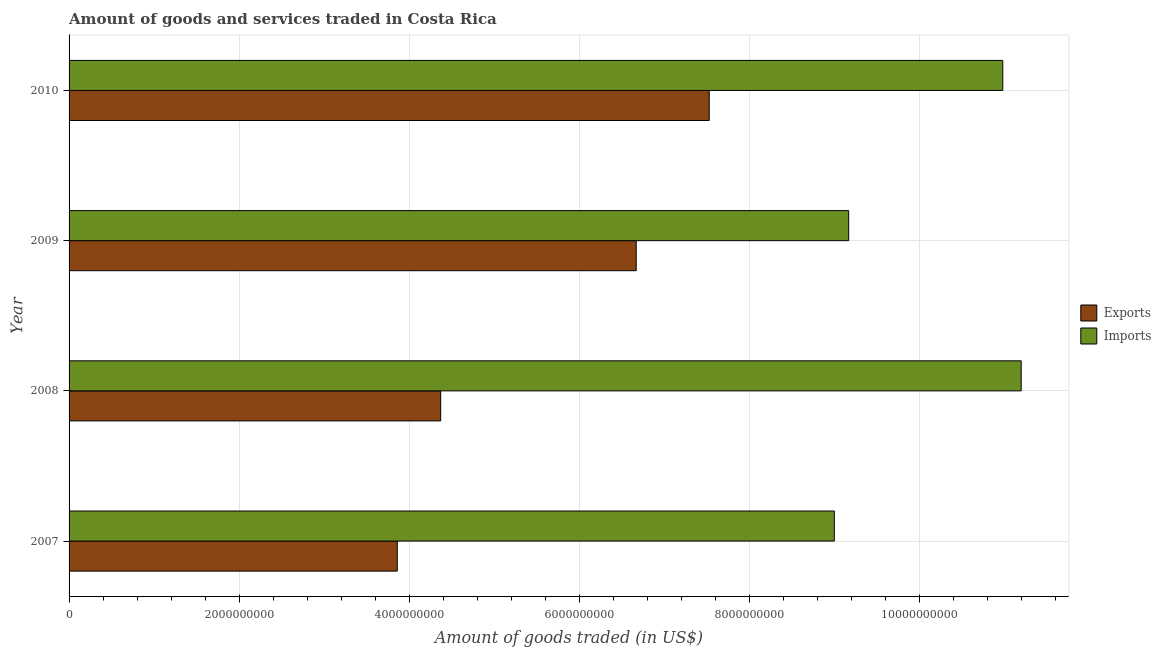Are the number of bars per tick equal to the number of legend labels?
Offer a very short reply. Yes. How many bars are there on the 4th tick from the top?
Your answer should be very brief. 2. How many bars are there on the 2nd tick from the bottom?
Keep it short and to the point. 2. In how many cases, is the number of bars for a given year not equal to the number of legend labels?
Give a very brief answer. 0. What is the amount of goods exported in 2010?
Your response must be concise. 7.53e+09. Across all years, what is the maximum amount of goods exported?
Your response must be concise. 7.53e+09. Across all years, what is the minimum amount of goods imported?
Provide a succinct answer. 9.00e+09. What is the total amount of goods exported in the graph?
Ensure brevity in your answer.  2.24e+1. What is the difference between the amount of goods exported in 2008 and that in 2010?
Offer a terse response. -3.16e+09. What is the difference between the amount of goods imported in 2008 and the amount of goods exported in 2010?
Keep it short and to the point. 3.67e+09. What is the average amount of goods exported per year?
Your response must be concise. 5.61e+09. In the year 2010, what is the difference between the amount of goods exported and amount of goods imported?
Keep it short and to the point. -3.45e+09. In how many years, is the amount of goods exported greater than 6800000000 US$?
Keep it short and to the point. 1. What is the ratio of the amount of goods exported in 2008 to that in 2009?
Your answer should be compact. 0.66. What is the difference between the highest and the second highest amount of goods imported?
Keep it short and to the point. 2.17e+08. What is the difference between the highest and the lowest amount of goods imported?
Your response must be concise. 2.20e+09. What does the 1st bar from the top in 2008 represents?
Offer a terse response. Imports. What does the 2nd bar from the bottom in 2009 represents?
Your answer should be very brief. Imports. Are all the bars in the graph horizontal?
Offer a very short reply. Yes. How many years are there in the graph?
Give a very brief answer. 4. How many legend labels are there?
Your answer should be very brief. 2. What is the title of the graph?
Your answer should be very brief. Amount of goods and services traded in Costa Rica. What is the label or title of the X-axis?
Provide a short and direct response. Amount of goods traded (in US$). What is the Amount of goods traded (in US$) in Exports in 2007?
Offer a terse response. 3.86e+09. What is the Amount of goods traded (in US$) in Imports in 2007?
Your response must be concise. 9.00e+09. What is the Amount of goods traded (in US$) in Exports in 2008?
Ensure brevity in your answer.  4.37e+09. What is the Amount of goods traded (in US$) in Imports in 2008?
Your response must be concise. 1.12e+1. What is the Amount of goods traded (in US$) in Exports in 2009?
Make the answer very short. 6.67e+09. What is the Amount of goods traded (in US$) of Imports in 2009?
Provide a succinct answer. 9.17e+09. What is the Amount of goods traded (in US$) in Exports in 2010?
Make the answer very short. 7.53e+09. What is the Amount of goods traded (in US$) of Imports in 2010?
Give a very brief answer. 1.10e+1. Across all years, what is the maximum Amount of goods traded (in US$) in Exports?
Offer a very short reply. 7.53e+09. Across all years, what is the maximum Amount of goods traded (in US$) in Imports?
Provide a succinct answer. 1.12e+1. Across all years, what is the minimum Amount of goods traded (in US$) in Exports?
Ensure brevity in your answer.  3.86e+09. Across all years, what is the minimum Amount of goods traded (in US$) in Imports?
Offer a very short reply. 9.00e+09. What is the total Amount of goods traded (in US$) of Exports in the graph?
Provide a succinct answer. 2.24e+1. What is the total Amount of goods traded (in US$) in Imports in the graph?
Offer a terse response. 4.04e+1. What is the difference between the Amount of goods traded (in US$) in Exports in 2007 and that in 2008?
Make the answer very short. -5.10e+08. What is the difference between the Amount of goods traded (in US$) in Imports in 2007 and that in 2008?
Make the answer very short. -2.20e+09. What is the difference between the Amount of goods traded (in US$) in Exports in 2007 and that in 2009?
Give a very brief answer. -2.81e+09. What is the difference between the Amount of goods traded (in US$) of Imports in 2007 and that in 2009?
Keep it short and to the point. -1.69e+08. What is the difference between the Amount of goods traded (in US$) of Exports in 2007 and that in 2010?
Your answer should be compact. -3.67e+09. What is the difference between the Amount of goods traded (in US$) in Imports in 2007 and that in 2010?
Keep it short and to the point. -1.98e+09. What is the difference between the Amount of goods traded (in US$) in Exports in 2008 and that in 2009?
Offer a terse response. -2.30e+09. What is the difference between the Amount of goods traded (in US$) of Imports in 2008 and that in 2009?
Make the answer very short. 2.03e+09. What is the difference between the Amount of goods traded (in US$) of Exports in 2008 and that in 2010?
Ensure brevity in your answer.  -3.16e+09. What is the difference between the Amount of goods traded (in US$) in Imports in 2008 and that in 2010?
Your answer should be compact. 2.17e+08. What is the difference between the Amount of goods traded (in US$) of Exports in 2009 and that in 2010?
Give a very brief answer. -8.59e+08. What is the difference between the Amount of goods traded (in US$) of Imports in 2009 and that in 2010?
Your response must be concise. -1.81e+09. What is the difference between the Amount of goods traded (in US$) in Exports in 2007 and the Amount of goods traded (in US$) in Imports in 2008?
Your answer should be very brief. -7.34e+09. What is the difference between the Amount of goods traded (in US$) in Exports in 2007 and the Amount of goods traded (in US$) in Imports in 2009?
Offer a terse response. -5.31e+09. What is the difference between the Amount of goods traded (in US$) of Exports in 2007 and the Amount of goods traded (in US$) of Imports in 2010?
Your answer should be compact. -7.12e+09. What is the difference between the Amount of goods traded (in US$) in Exports in 2008 and the Amount of goods traded (in US$) in Imports in 2009?
Keep it short and to the point. -4.80e+09. What is the difference between the Amount of goods traded (in US$) in Exports in 2008 and the Amount of goods traded (in US$) in Imports in 2010?
Keep it short and to the point. -6.61e+09. What is the difference between the Amount of goods traded (in US$) of Exports in 2009 and the Amount of goods traded (in US$) of Imports in 2010?
Make the answer very short. -4.31e+09. What is the average Amount of goods traded (in US$) in Exports per year?
Offer a terse response. 5.61e+09. What is the average Amount of goods traded (in US$) of Imports per year?
Provide a succinct answer. 1.01e+1. In the year 2007, what is the difference between the Amount of goods traded (in US$) of Exports and Amount of goods traded (in US$) of Imports?
Give a very brief answer. -5.14e+09. In the year 2008, what is the difference between the Amount of goods traded (in US$) of Exports and Amount of goods traded (in US$) of Imports?
Offer a very short reply. -6.83e+09. In the year 2009, what is the difference between the Amount of goods traded (in US$) of Exports and Amount of goods traded (in US$) of Imports?
Give a very brief answer. -2.50e+09. In the year 2010, what is the difference between the Amount of goods traded (in US$) of Exports and Amount of goods traded (in US$) of Imports?
Ensure brevity in your answer.  -3.45e+09. What is the ratio of the Amount of goods traded (in US$) in Exports in 2007 to that in 2008?
Provide a succinct answer. 0.88. What is the ratio of the Amount of goods traded (in US$) in Imports in 2007 to that in 2008?
Provide a short and direct response. 0.8. What is the ratio of the Amount of goods traded (in US$) of Exports in 2007 to that in 2009?
Your answer should be compact. 0.58. What is the ratio of the Amount of goods traded (in US$) of Imports in 2007 to that in 2009?
Ensure brevity in your answer.  0.98. What is the ratio of the Amount of goods traded (in US$) in Exports in 2007 to that in 2010?
Keep it short and to the point. 0.51. What is the ratio of the Amount of goods traded (in US$) of Imports in 2007 to that in 2010?
Keep it short and to the point. 0.82. What is the ratio of the Amount of goods traded (in US$) of Exports in 2008 to that in 2009?
Offer a terse response. 0.66. What is the ratio of the Amount of goods traded (in US$) of Imports in 2008 to that in 2009?
Your response must be concise. 1.22. What is the ratio of the Amount of goods traded (in US$) in Exports in 2008 to that in 2010?
Offer a terse response. 0.58. What is the ratio of the Amount of goods traded (in US$) in Imports in 2008 to that in 2010?
Your answer should be compact. 1.02. What is the ratio of the Amount of goods traded (in US$) in Exports in 2009 to that in 2010?
Your answer should be compact. 0.89. What is the ratio of the Amount of goods traded (in US$) in Imports in 2009 to that in 2010?
Ensure brevity in your answer.  0.83. What is the difference between the highest and the second highest Amount of goods traded (in US$) of Exports?
Offer a very short reply. 8.59e+08. What is the difference between the highest and the second highest Amount of goods traded (in US$) in Imports?
Make the answer very short. 2.17e+08. What is the difference between the highest and the lowest Amount of goods traded (in US$) of Exports?
Provide a short and direct response. 3.67e+09. What is the difference between the highest and the lowest Amount of goods traded (in US$) of Imports?
Keep it short and to the point. 2.20e+09. 